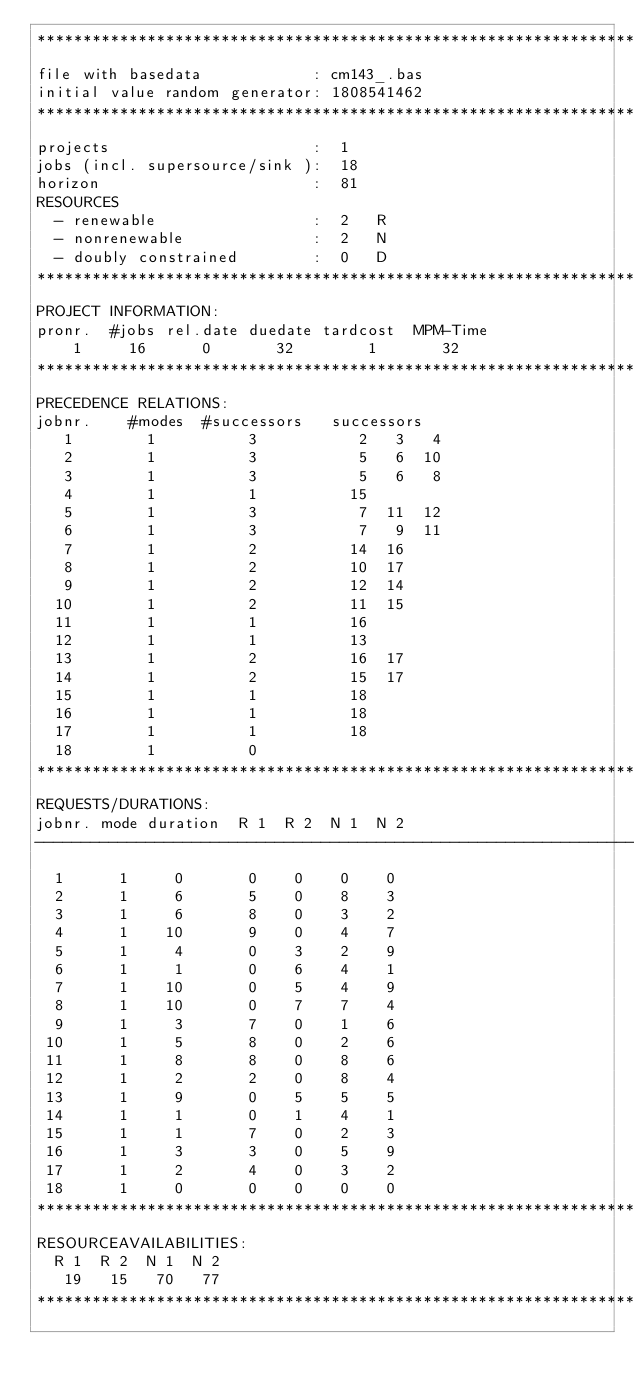Convert code to text. <code><loc_0><loc_0><loc_500><loc_500><_ObjectiveC_>************************************************************************
file with basedata            : cm143_.bas
initial value random generator: 1808541462
************************************************************************
projects                      :  1
jobs (incl. supersource/sink ):  18
horizon                       :  81
RESOURCES
  - renewable                 :  2   R
  - nonrenewable              :  2   N
  - doubly constrained        :  0   D
************************************************************************
PROJECT INFORMATION:
pronr.  #jobs rel.date duedate tardcost  MPM-Time
    1     16      0       32        1       32
************************************************************************
PRECEDENCE RELATIONS:
jobnr.    #modes  #successors   successors
   1        1          3           2   3   4
   2        1          3           5   6  10
   3        1          3           5   6   8
   4        1          1          15
   5        1          3           7  11  12
   6        1          3           7   9  11
   7        1          2          14  16
   8        1          2          10  17
   9        1          2          12  14
  10        1          2          11  15
  11        1          1          16
  12        1          1          13
  13        1          2          16  17
  14        1          2          15  17
  15        1          1          18
  16        1          1          18
  17        1          1          18
  18        1          0        
************************************************************************
REQUESTS/DURATIONS:
jobnr. mode duration  R 1  R 2  N 1  N 2
------------------------------------------------------------------------
  1      1     0       0    0    0    0
  2      1     6       5    0    8    3
  3      1     6       8    0    3    2
  4      1    10       9    0    4    7
  5      1     4       0    3    2    9
  6      1     1       0    6    4    1
  7      1    10       0    5    4    9
  8      1    10       0    7    7    4
  9      1     3       7    0    1    6
 10      1     5       8    0    2    6
 11      1     8       8    0    8    6
 12      1     2       2    0    8    4
 13      1     9       0    5    5    5
 14      1     1       0    1    4    1
 15      1     1       7    0    2    3
 16      1     3       3    0    5    9
 17      1     2       4    0    3    2
 18      1     0       0    0    0    0
************************************************************************
RESOURCEAVAILABILITIES:
  R 1  R 2  N 1  N 2
   19   15   70   77
************************************************************************
</code> 